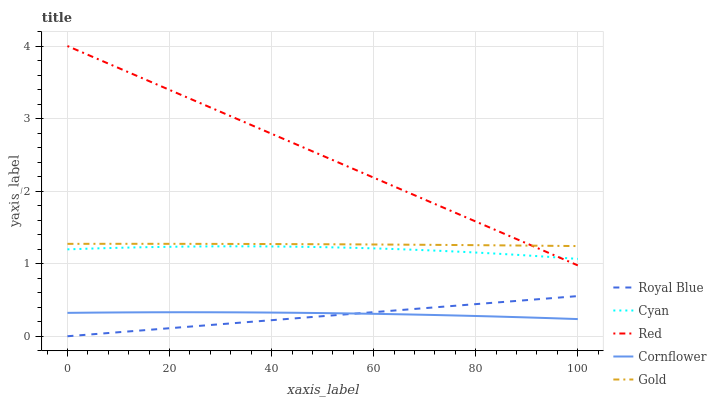Does Royal Blue have the minimum area under the curve?
Answer yes or no. Yes. Does Red have the maximum area under the curve?
Answer yes or no. Yes. Does Gold have the minimum area under the curve?
Answer yes or no. No. Does Gold have the maximum area under the curve?
Answer yes or no. No. Is Royal Blue the smoothest?
Answer yes or no. Yes. Is Cyan the roughest?
Answer yes or no. Yes. Is Gold the smoothest?
Answer yes or no. No. Is Gold the roughest?
Answer yes or no. No. Does Royal Blue have the lowest value?
Answer yes or no. Yes. Does Cornflower have the lowest value?
Answer yes or no. No. Does Red have the highest value?
Answer yes or no. Yes. Does Gold have the highest value?
Answer yes or no. No. Is Royal Blue less than Cyan?
Answer yes or no. Yes. Is Gold greater than Royal Blue?
Answer yes or no. Yes. Does Gold intersect Red?
Answer yes or no. Yes. Is Gold less than Red?
Answer yes or no. No. Is Gold greater than Red?
Answer yes or no. No. Does Royal Blue intersect Cyan?
Answer yes or no. No. 